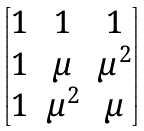<formula> <loc_0><loc_0><loc_500><loc_500>\begin{bmatrix} 1 & 1 & 1 \\ 1 & \mu & \mu ^ { 2 } \\ 1 & \mu ^ { 2 } & \mu \\ \end{bmatrix}</formula> 